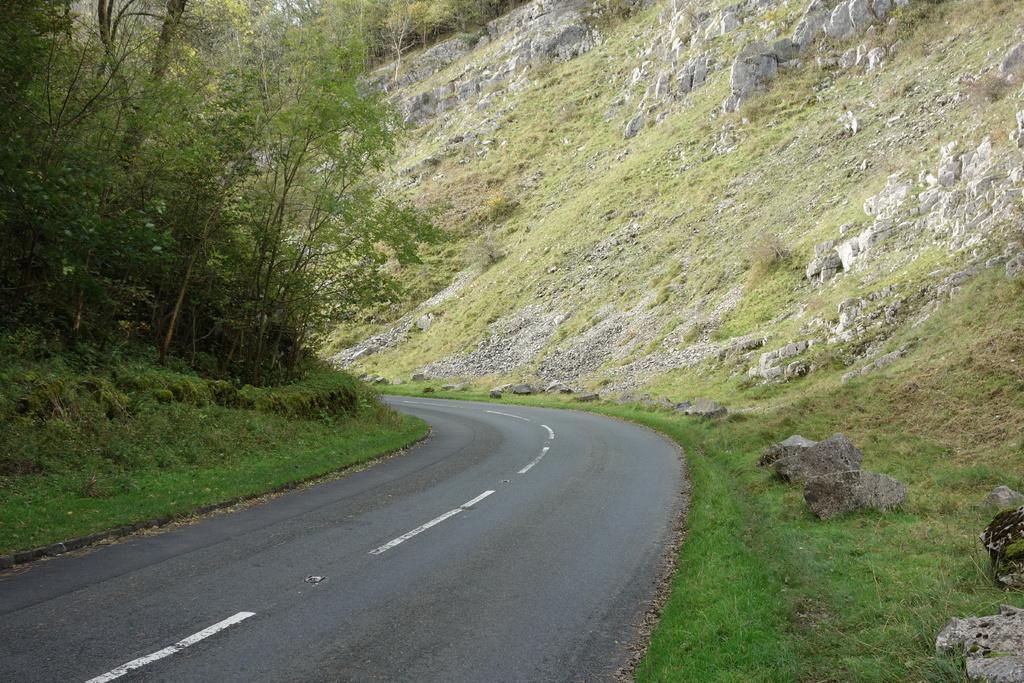Could you give a brief overview of what you see in this image? In this image we can see the road, near that we can see grass, after that we can see the stones, we can see the trees. 